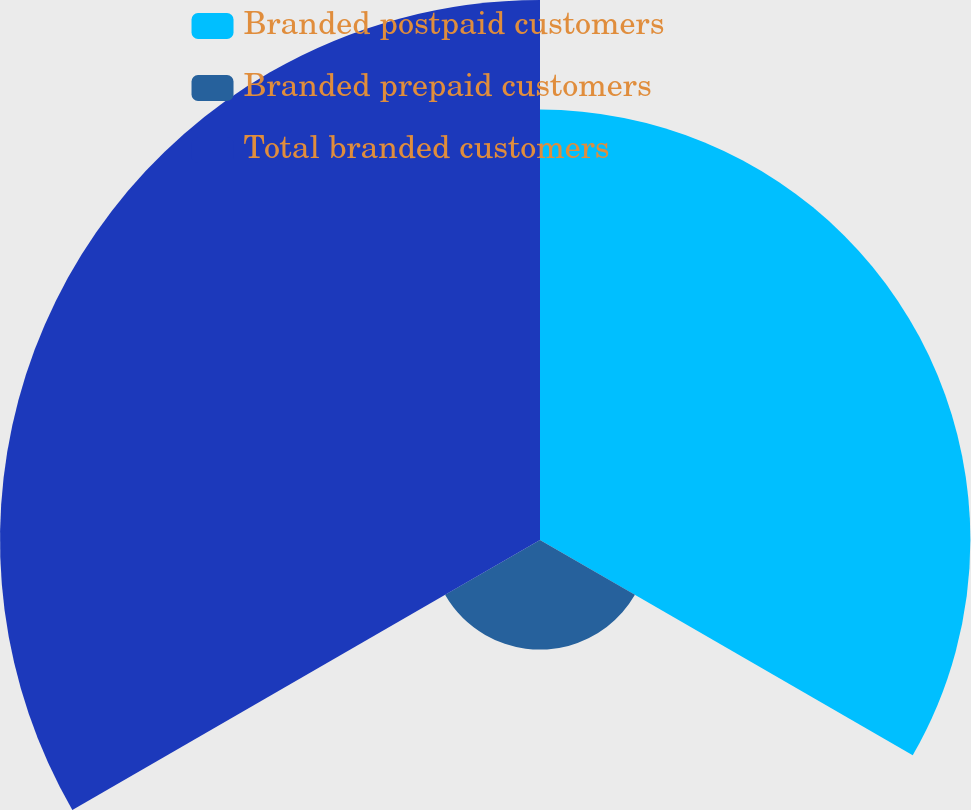Convert chart. <chart><loc_0><loc_0><loc_500><loc_500><pie_chart><fcel>Branded postpaid customers<fcel>Branded prepaid customers<fcel>Total branded customers<nl><fcel>39.85%<fcel>10.15%<fcel>50.0%<nl></chart> 